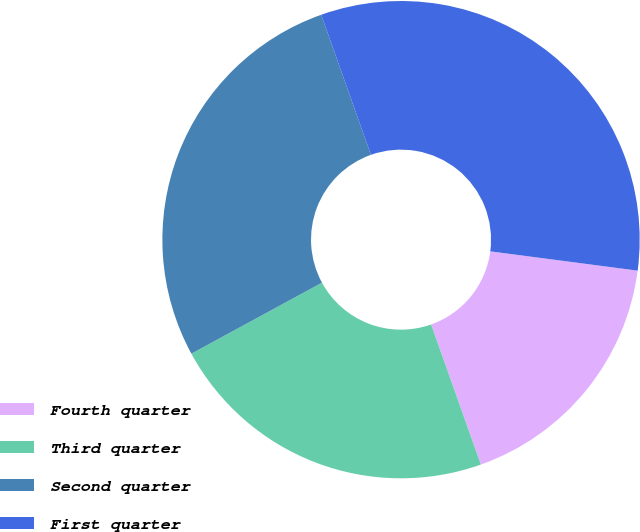<chart> <loc_0><loc_0><loc_500><loc_500><pie_chart><fcel>Fourth quarter<fcel>Third quarter<fcel>Second quarter<fcel>First quarter<nl><fcel>17.5%<fcel>22.5%<fcel>27.5%<fcel>32.5%<nl></chart> 